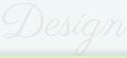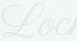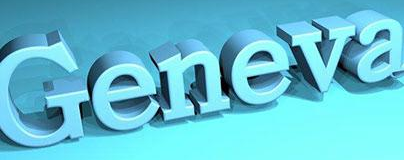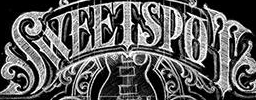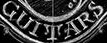Transcribe the words shown in these images in order, separated by a semicolon. Design; Loc; Geneva; SWEETSPOT; GUITARS 